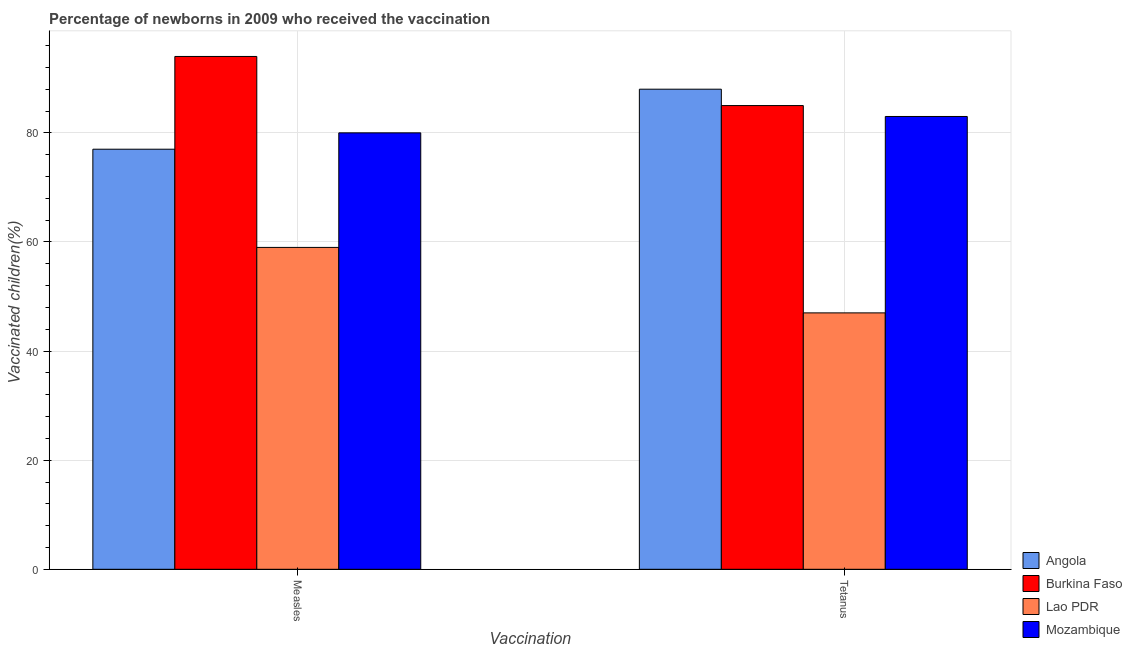Are the number of bars per tick equal to the number of legend labels?
Offer a terse response. Yes. How many bars are there on the 1st tick from the left?
Provide a succinct answer. 4. What is the label of the 2nd group of bars from the left?
Provide a succinct answer. Tetanus. What is the percentage of newborns who received vaccination for measles in Lao PDR?
Your answer should be compact. 59. Across all countries, what is the maximum percentage of newborns who received vaccination for tetanus?
Your answer should be compact. 88. Across all countries, what is the minimum percentage of newborns who received vaccination for tetanus?
Ensure brevity in your answer.  47. In which country was the percentage of newborns who received vaccination for tetanus maximum?
Your answer should be compact. Angola. In which country was the percentage of newborns who received vaccination for measles minimum?
Your response must be concise. Lao PDR. What is the total percentage of newborns who received vaccination for tetanus in the graph?
Your response must be concise. 303. What is the difference between the percentage of newborns who received vaccination for tetanus in Mozambique and that in Burkina Faso?
Your answer should be very brief. -2. What is the difference between the percentage of newborns who received vaccination for tetanus in Burkina Faso and the percentage of newborns who received vaccination for measles in Lao PDR?
Make the answer very short. 26. What is the average percentage of newborns who received vaccination for measles per country?
Give a very brief answer. 77.5. What is the difference between the percentage of newborns who received vaccination for measles and percentage of newborns who received vaccination for tetanus in Burkina Faso?
Offer a very short reply. 9. What is the ratio of the percentage of newborns who received vaccination for measles in Mozambique to that in Angola?
Your response must be concise. 1.04. Is the percentage of newborns who received vaccination for tetanus in Angola less than that in Burkina Faso?
Keep it short and to the point. No. What does the 2nd bar from the left in Measles represents?
Provide a short and direct response. Burkina Faso. What does the 2nd bar from the right in Measles represents?
Your answer should be compact. Lao PDR. How many bars are there?
Keep it short and to the point. 8. Are all the bars in the graph horizontal?
Your answer should be very brief. No. What is the difference between two consecutive major ticks on the Y-axis?
Your answer should be compact. 20. Are the values on the major ticks of Y-axis written in scientific E-notation?
Make the answer very short. No. Where does the legend appear in the graph?
Keep it short and to the point. Bottom right. How many legend labels are there?
Your response must be concise. 4. What is the title of the graph?
Keep it short and to the point. Percentage of newborns in 2009 who received the vaccination. Does "Czech Republic" appear as one of the legend labels in the graph?
Offer a terse response. No. What is the label or title of the X-axis?
Your answer should be compact. Vaccination. What is the label or title of the Y-axis?
Your answer should be compact. Vaccinated children(%)
. What is the Vaccinated children(%)
 in Angola in Measles?
Ensure brevity in your answer.  77. What is the Vaccinated children(%)
 in Burkina Faso in Measles?
Your response must be concise. 94. What is the Vaccinated children(%)
 in Lao PDR in Measles?
Your answer should be compact. 59. What is the Vaccinated children(%)
 in Mozambique in Measles?
Ensure brevity in your answer.  80. What is the Vaccinated children(%)
 in Angola in Tetanus?
Provide a short and direct response. 88. What is the Vaccinated children(%)
 in Burkina Faso in Tetanus?
Offer a terse response. 85. What is the Vaccinated children(%)
 in Mozambique in Tetanus?
Provide a succinct answer. 83. Across all Vaccination, what is the maximum Vaccinated children(%)
 in Burkina Faso?
Keep it short and to the point. 94. Across all Vaccination, what is the maximum Vaccinated children(%)
 of Mozambique?
Provide a succinct answer. 83. Across all Vaccination, what is the minimum Vaccinated children(%)
 of Angola?
Offer a terse response. 77. Across all Vaccination, what is the minimum Vaccinated children(%)
 in Mozambique?
Keep it short and to the point. 80. What is the total Vaccinated children(%)
 in Angola in the graph?
Provide a short and direct response. 165. What is the total Vaccinated children(%)
 in Burkina Faso in the graph?
Keep it short and to the point. 179. What is the total Vaccinated children(%)
 in Lao PDR in the graph?
Ensure brevity in your answer.  106. What is the total Vaccinated children(%)
 in Mozambique in the graph?
Your response must be concise. 163. What is the difference between the Vaccinated children(%)
 of Burkina Faso in Measles and that in Tetanus?
Make the answer very short. 9. What is the difference between the Vaccinated children(%)
 of Lao PDR in Measles and that in Tetanus?
Ensure brevity in your answer.  12. What is the difference between the Vaccinated children(%)
 of Mozambique in Measles and that in Tetanus?
Offer a very short reply. -3. What is the difference between the Vaccinated children(%)
 in Angola in Measles and the Vaccinated children(%)
 in Lao PDR in Tetanus?
Provide a short and direct response. 30. What is the difference between the Vaccinated children(%)
 in Angola in Measles and the Vaccinated children(%)
 in Mozambique in Tetanus?
Offer a terse response. -6. What is the difference between the Vaccinated children(%)
 in Burkina Faso in Measles and the Vaccinated children(%)
 in Lao PDR in Tetanus?
Provide a succinct answer. 47. What is the average Vaccinated children(%)
 in Angola per Vaccination?
Give a very brief answer. 82.5. What is the average Vaccinated children(%)
 of Burkina Faso per Vaccination?
Provide a succinct answer. 89.5. What is the average Vaccinated children(%)
 in Lao PDR per Vaccination?
Provide a short and direct response. 53. What is the average Vaccinated children(%)
 of Mozambique per Vaccination?
Provide a short and direct response. 81.5. What is the difference between the Vaccinated children(%)
 in Angola and Vaccinated children(%)
 in Burkina Faso in Measles?
Give a very brief answer. -17. What is the difference between the Vaccinated children(%)
 in Angola and Vaccinated children(%)
 in Mozambique in Measles?
Make the answer very short. -3. What is the difference between the Vaccinated children(%)
 in Burkina Faso and Vaccinated children(%)
 in Mozambique in Measles?
Offer a terse response. 14. What is the difference between the Vaccinated children(%)
 of Angola and Vaccinated children(%)
 of Burkina Faso in Tetanus?
Keep it short and to the point. 3. What is the difference between the Vaccinated children(%)
 of Angola and Vaccinated children(%)
 of Mozambique in Tetanus?
Provide a succinct answer. 5. What is the difference between the Vaccinated children(%)
 in Burkina Faso and Vaccinated children(%)
 in Lao PDR in Tetanus?
Make the answer very short. 38. What is the difference between the Vaccinated children(%)
 in Lao PDR and Vaccinated children(%)
 in Mozambique in Tetanus?
Ensure brevity in your answer.  -36. What is the ratio of the Vaccinated children(%)
 in Burkina Faso in Measles to that in Tetanus?
Your response must be concise. 1.11. What is the ratio of the Vaccinated children(%)
 of Lao PDR in Measles to that in Tetanus?
Give a very brief answer. 1.26. What is the ratio of the Vaccinated children(%)
 in Mozambique in Measles to that in Tetanus?
Offer a terse response. 0.96. What is the difference between the highest and the second highest Vaccinated children(%)
 in Angola?
Make the answer very short. 11. What is the difference between the highest and the second highest Vaccinated children(%)
 of Mozambique?
Offer a terse response. 3. What is the difference between the highest and the lowest Vaccinated children(%)
 of Lao PDR?
Ensure brevity in your answer.  12. 